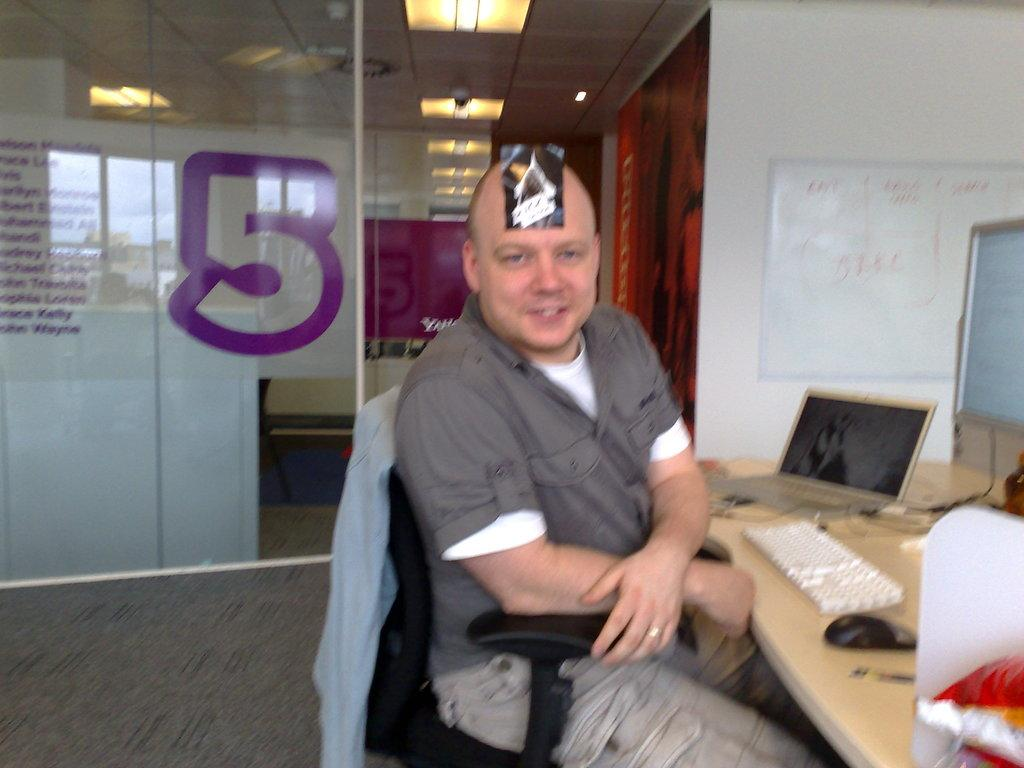What is the man in the image doing? The man is sitting on a chair in the image. What objects are on the table in the image? There is a keyboard, a mouse, a laptop, and a monitor on the table in the image. What is on the wall in the image? There is a whiteboard on the wall in the image. What type of pear is the laborer holding in the image? There is no laborer or pear present in the image. What is the wire used for in the image? There is no wire present in the image. 